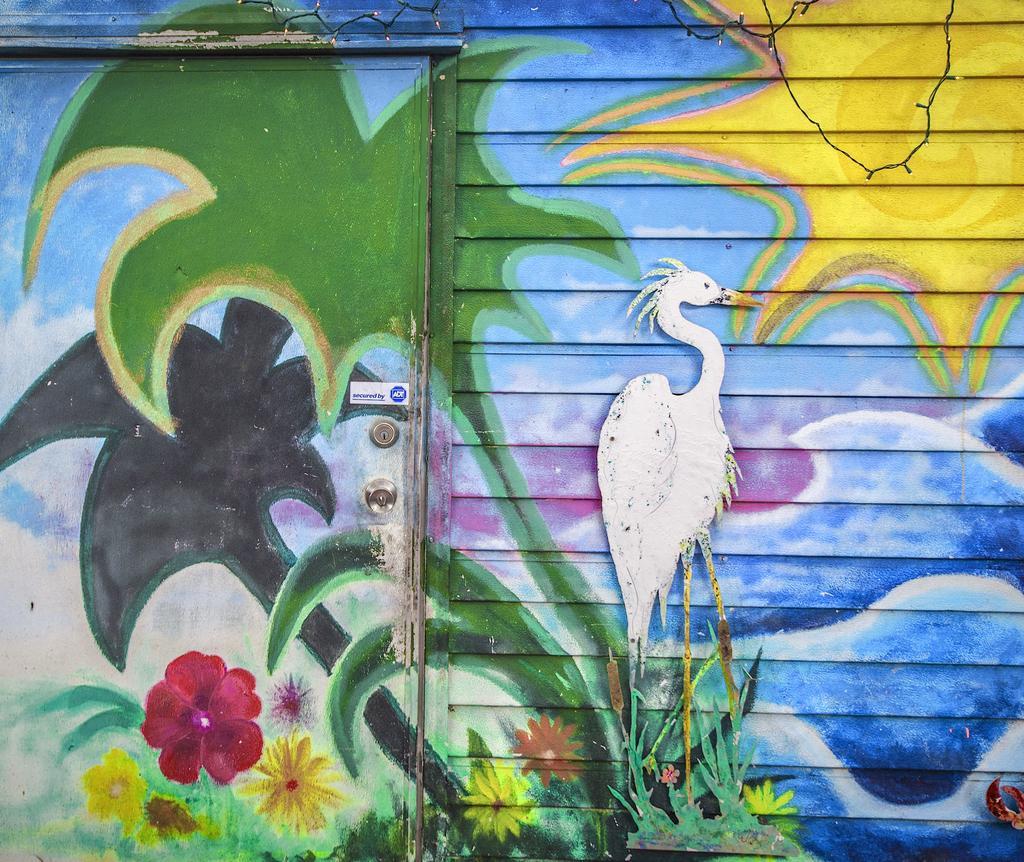Please provide a concise description of this image. This is a picture of a wall and door. In this picture there is a painting of trees, flowers, crane, water and sun. In the painting sky is cloudy. On the left there is a door. 